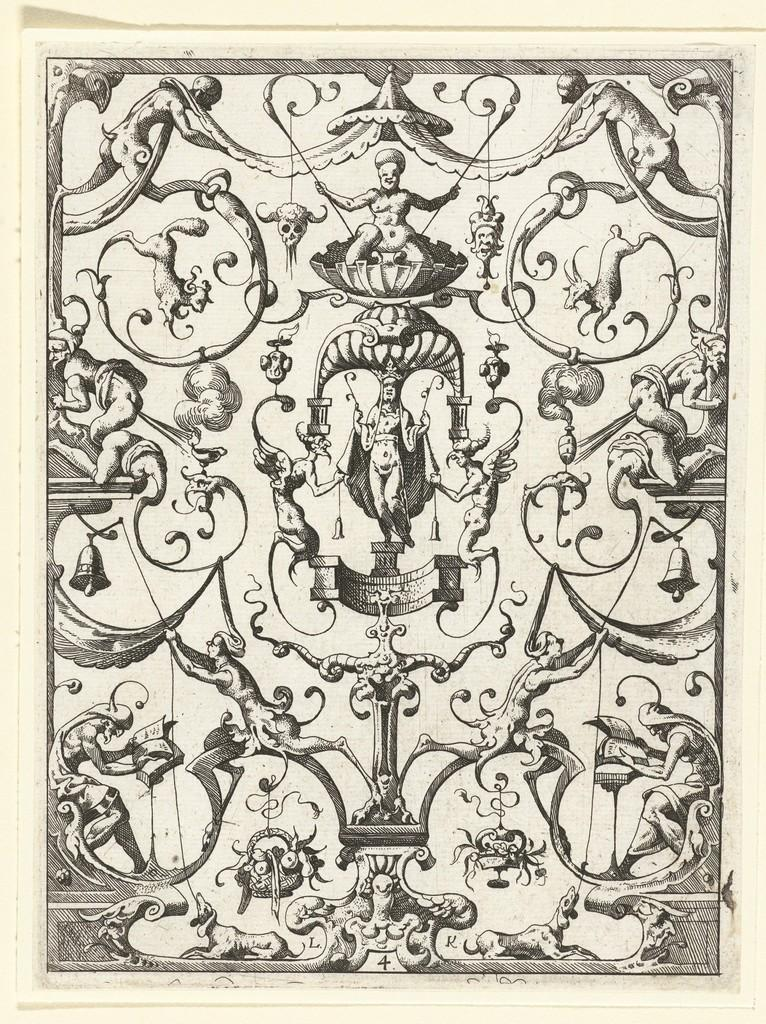What is the main subject of the image? The main subject of the image is a paper with different pictures on it. Can you describe the pictures on the paper? Unfortunately, the specific details of the pictures cannot be determined from the provided fact. What might be the purpose of having multiple pictures on a single paper? The purpose of having multiple pictures on a single paper could be for various reasons, such as a collage, a presentation, or a collection of related images. What type of slope can be seen in the image? There is no slope present in the image; it features a paper with different pictures on it. How many steps are visible in the image? There are no steps visible in the image; it features a paper with different pictures on it. 